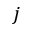Convert formula to latex. <formula><loc_0><loc_0><loc_500><loc_500>j</formula> 